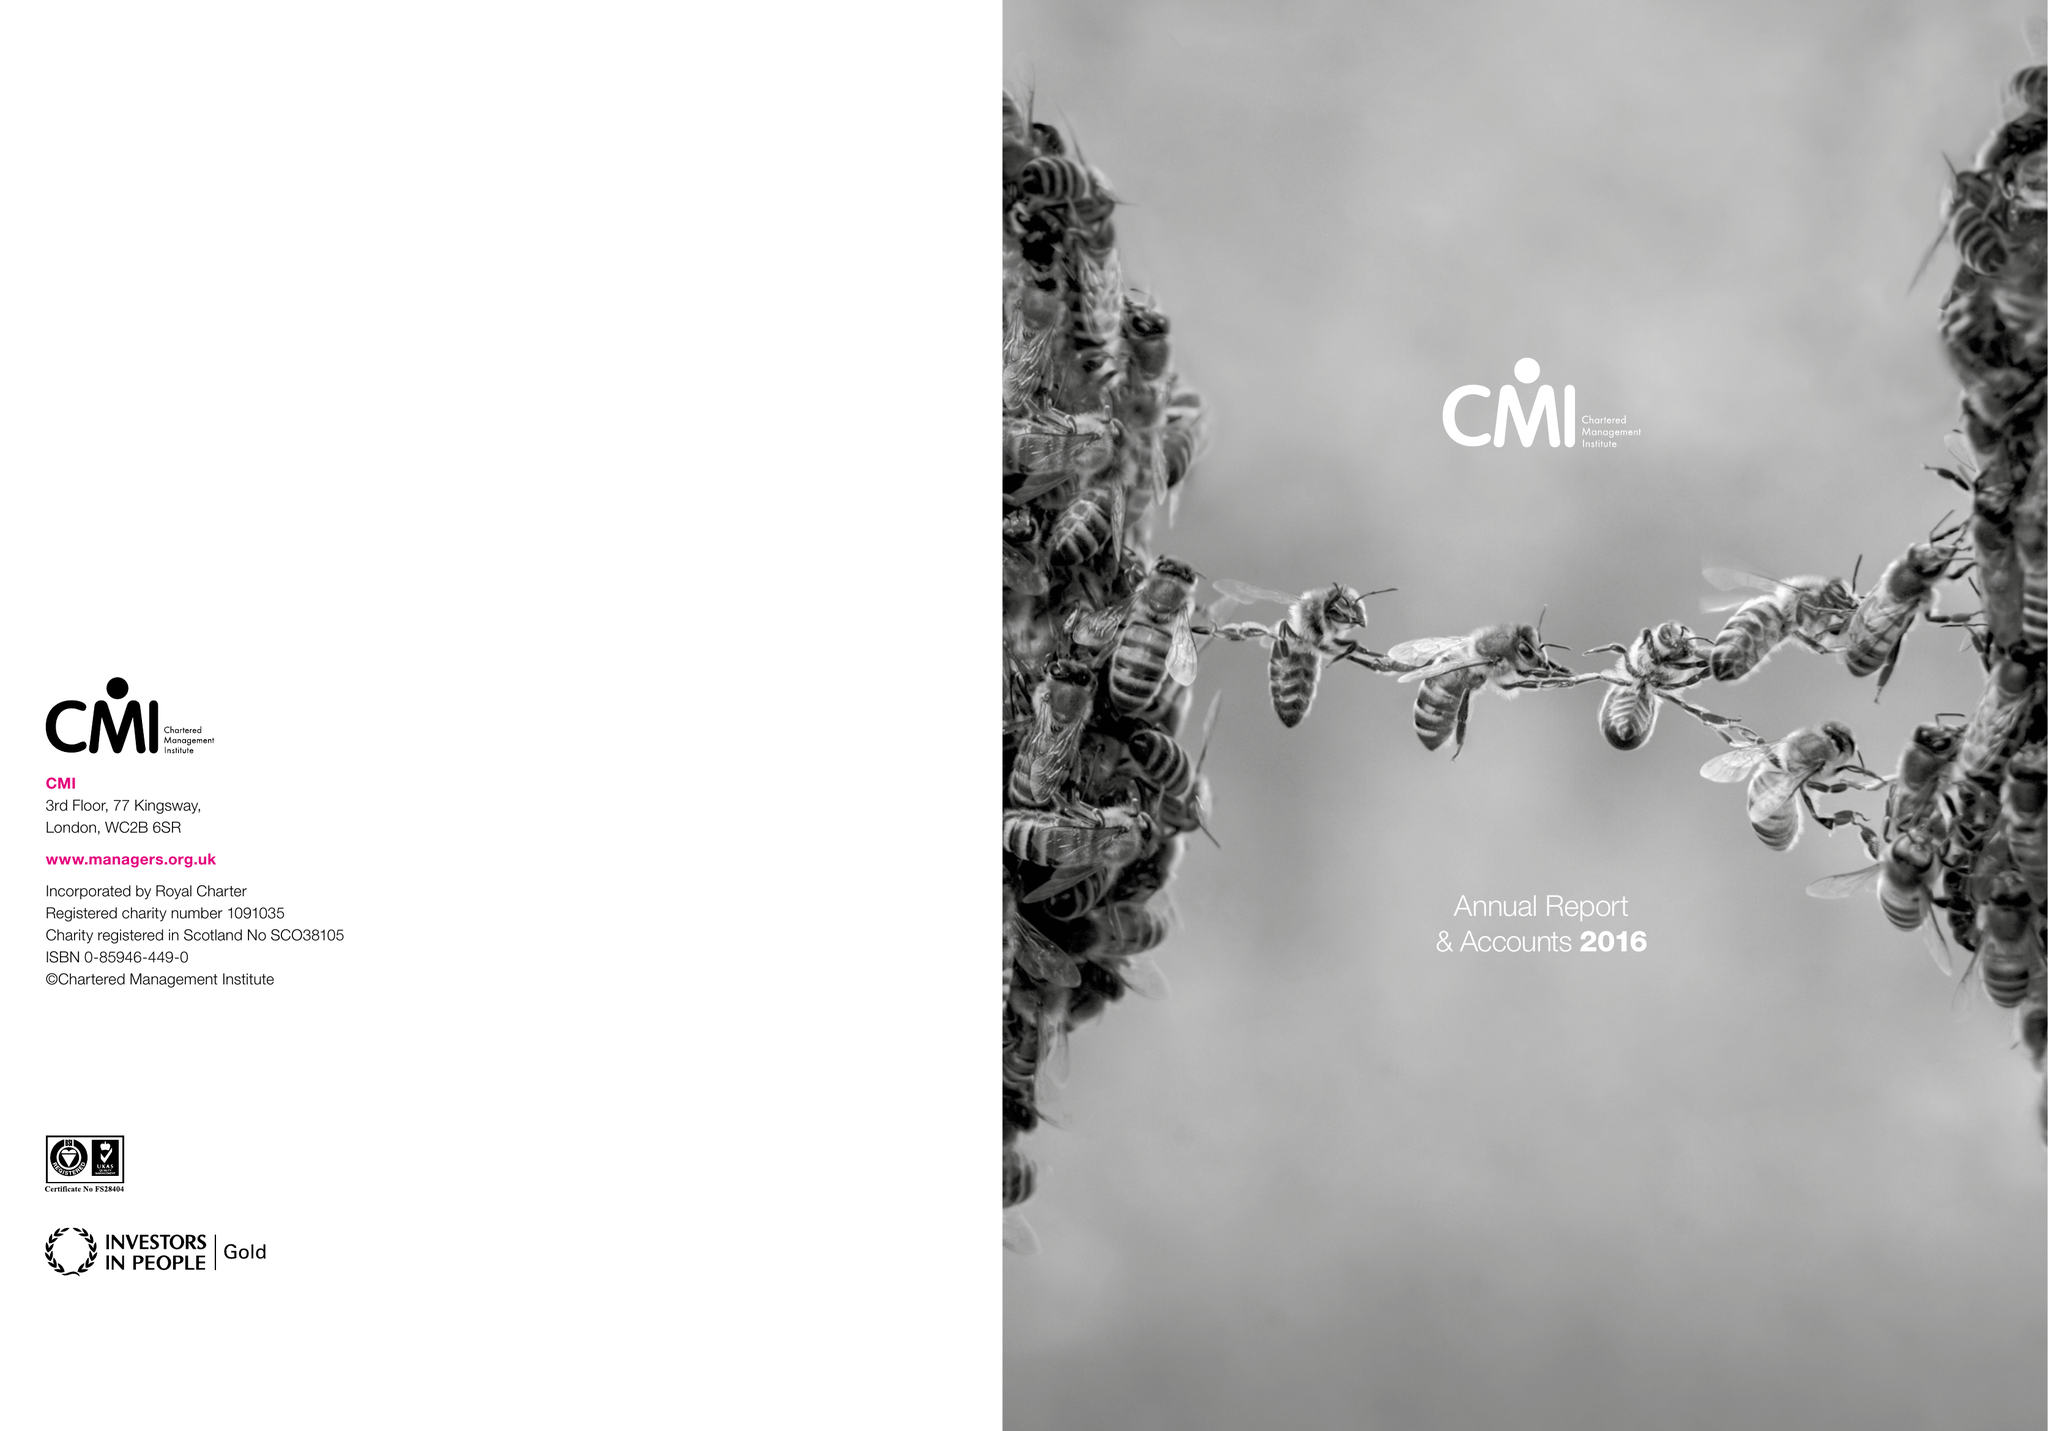What is the value for the address__street_line?
Answer the question using a single word or phrase. COTTINGHAM ROAD 